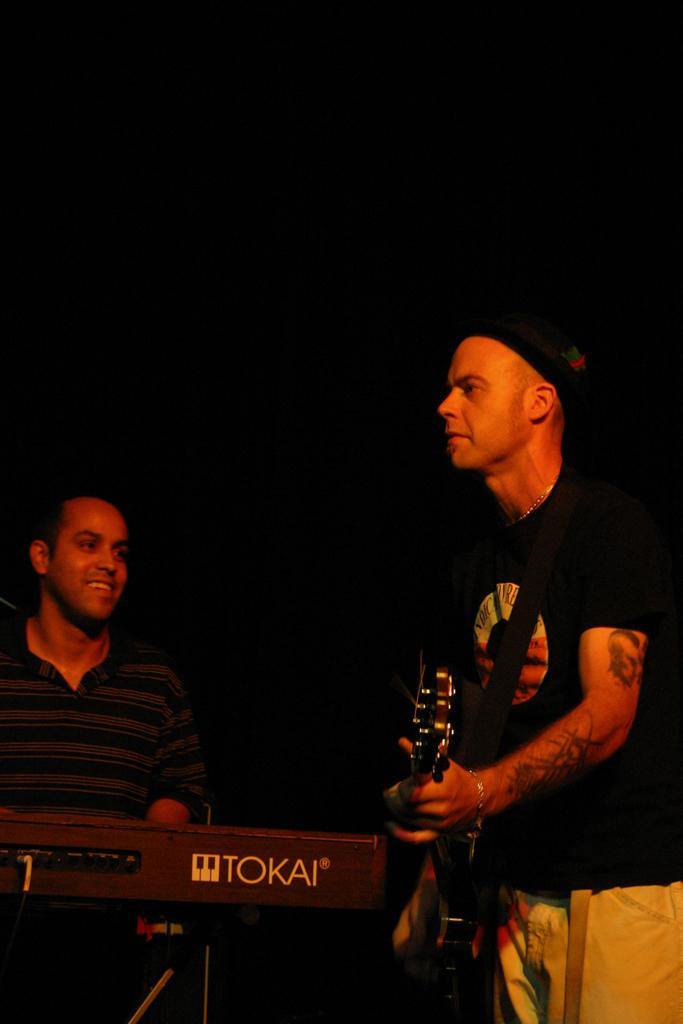Who is the main subject on the right side of the image? There is a man on the right side of the image. What is the man wearing? The man is wearing a black t-shirt. What is the man doing in the image? The man is playing a guitar. Can you describe the second man in the image? There is another man in the image, and he is playing a keyboard. What expression does the second man have? The second man is smiling. What type of creature can be seen writing in a notebook on the coast in the image? There is no creature or notebook present on the coast in the image. 